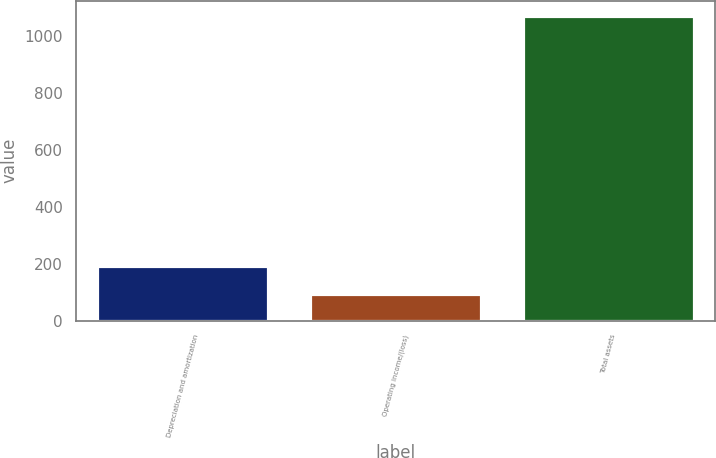Convert chart to OTSL. <chart><loc_0><loc_0><loc_500><loc_500><bar_chart><fcel>Depreciation and amortization<fcel>Operating income/(loss)<fcel>Total assets<nl><fcel>190.74<fcel>92.9<fcel>1071.3<nl></chart> 